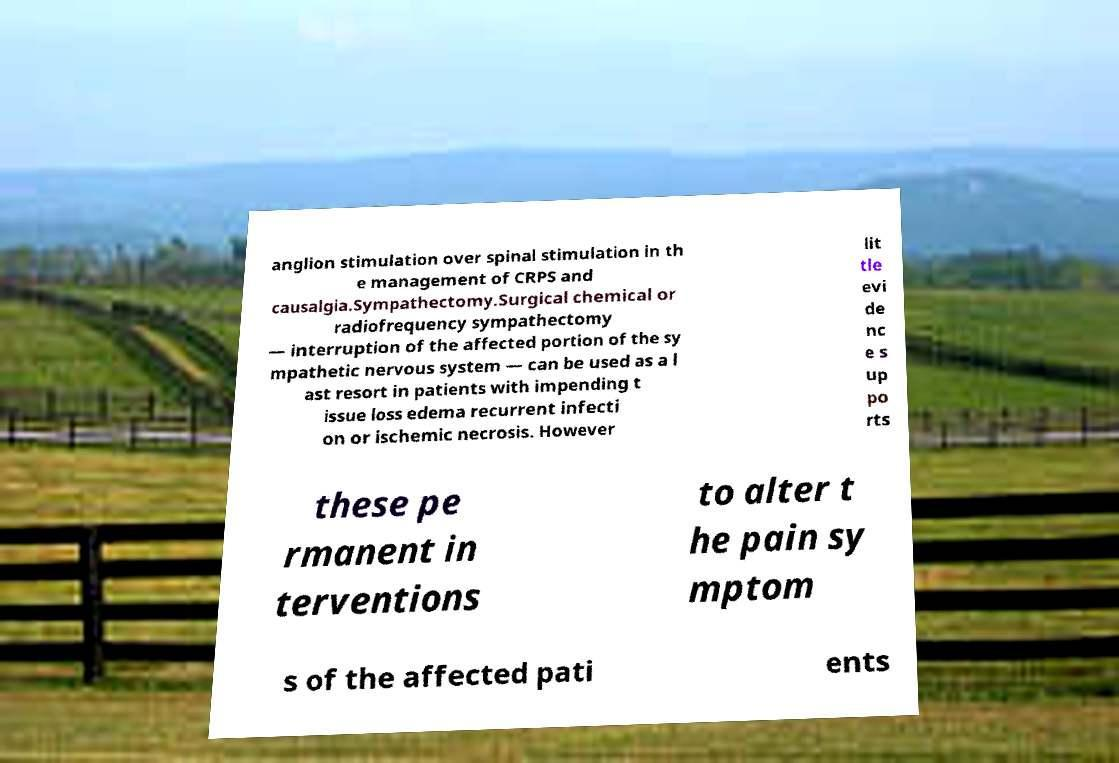Can you accurately transcribe the text from the provided image for me? anglion stimulation over spinal stimulation in th e management of CRPS and causalgia.Sympathectomy.Surgical chemical or radiofrequency sympathectomy — interruption of the affected portion of the sy mpathetic nervous system — can be used as a l ast resort in patients with impending t issue loss edema recurrent infecti on or ischemic necrosis. However lit tle evi de nc e s up po rts these pe rmanent in terventions to alter t he pain sy mptom s of the affected pati ents 